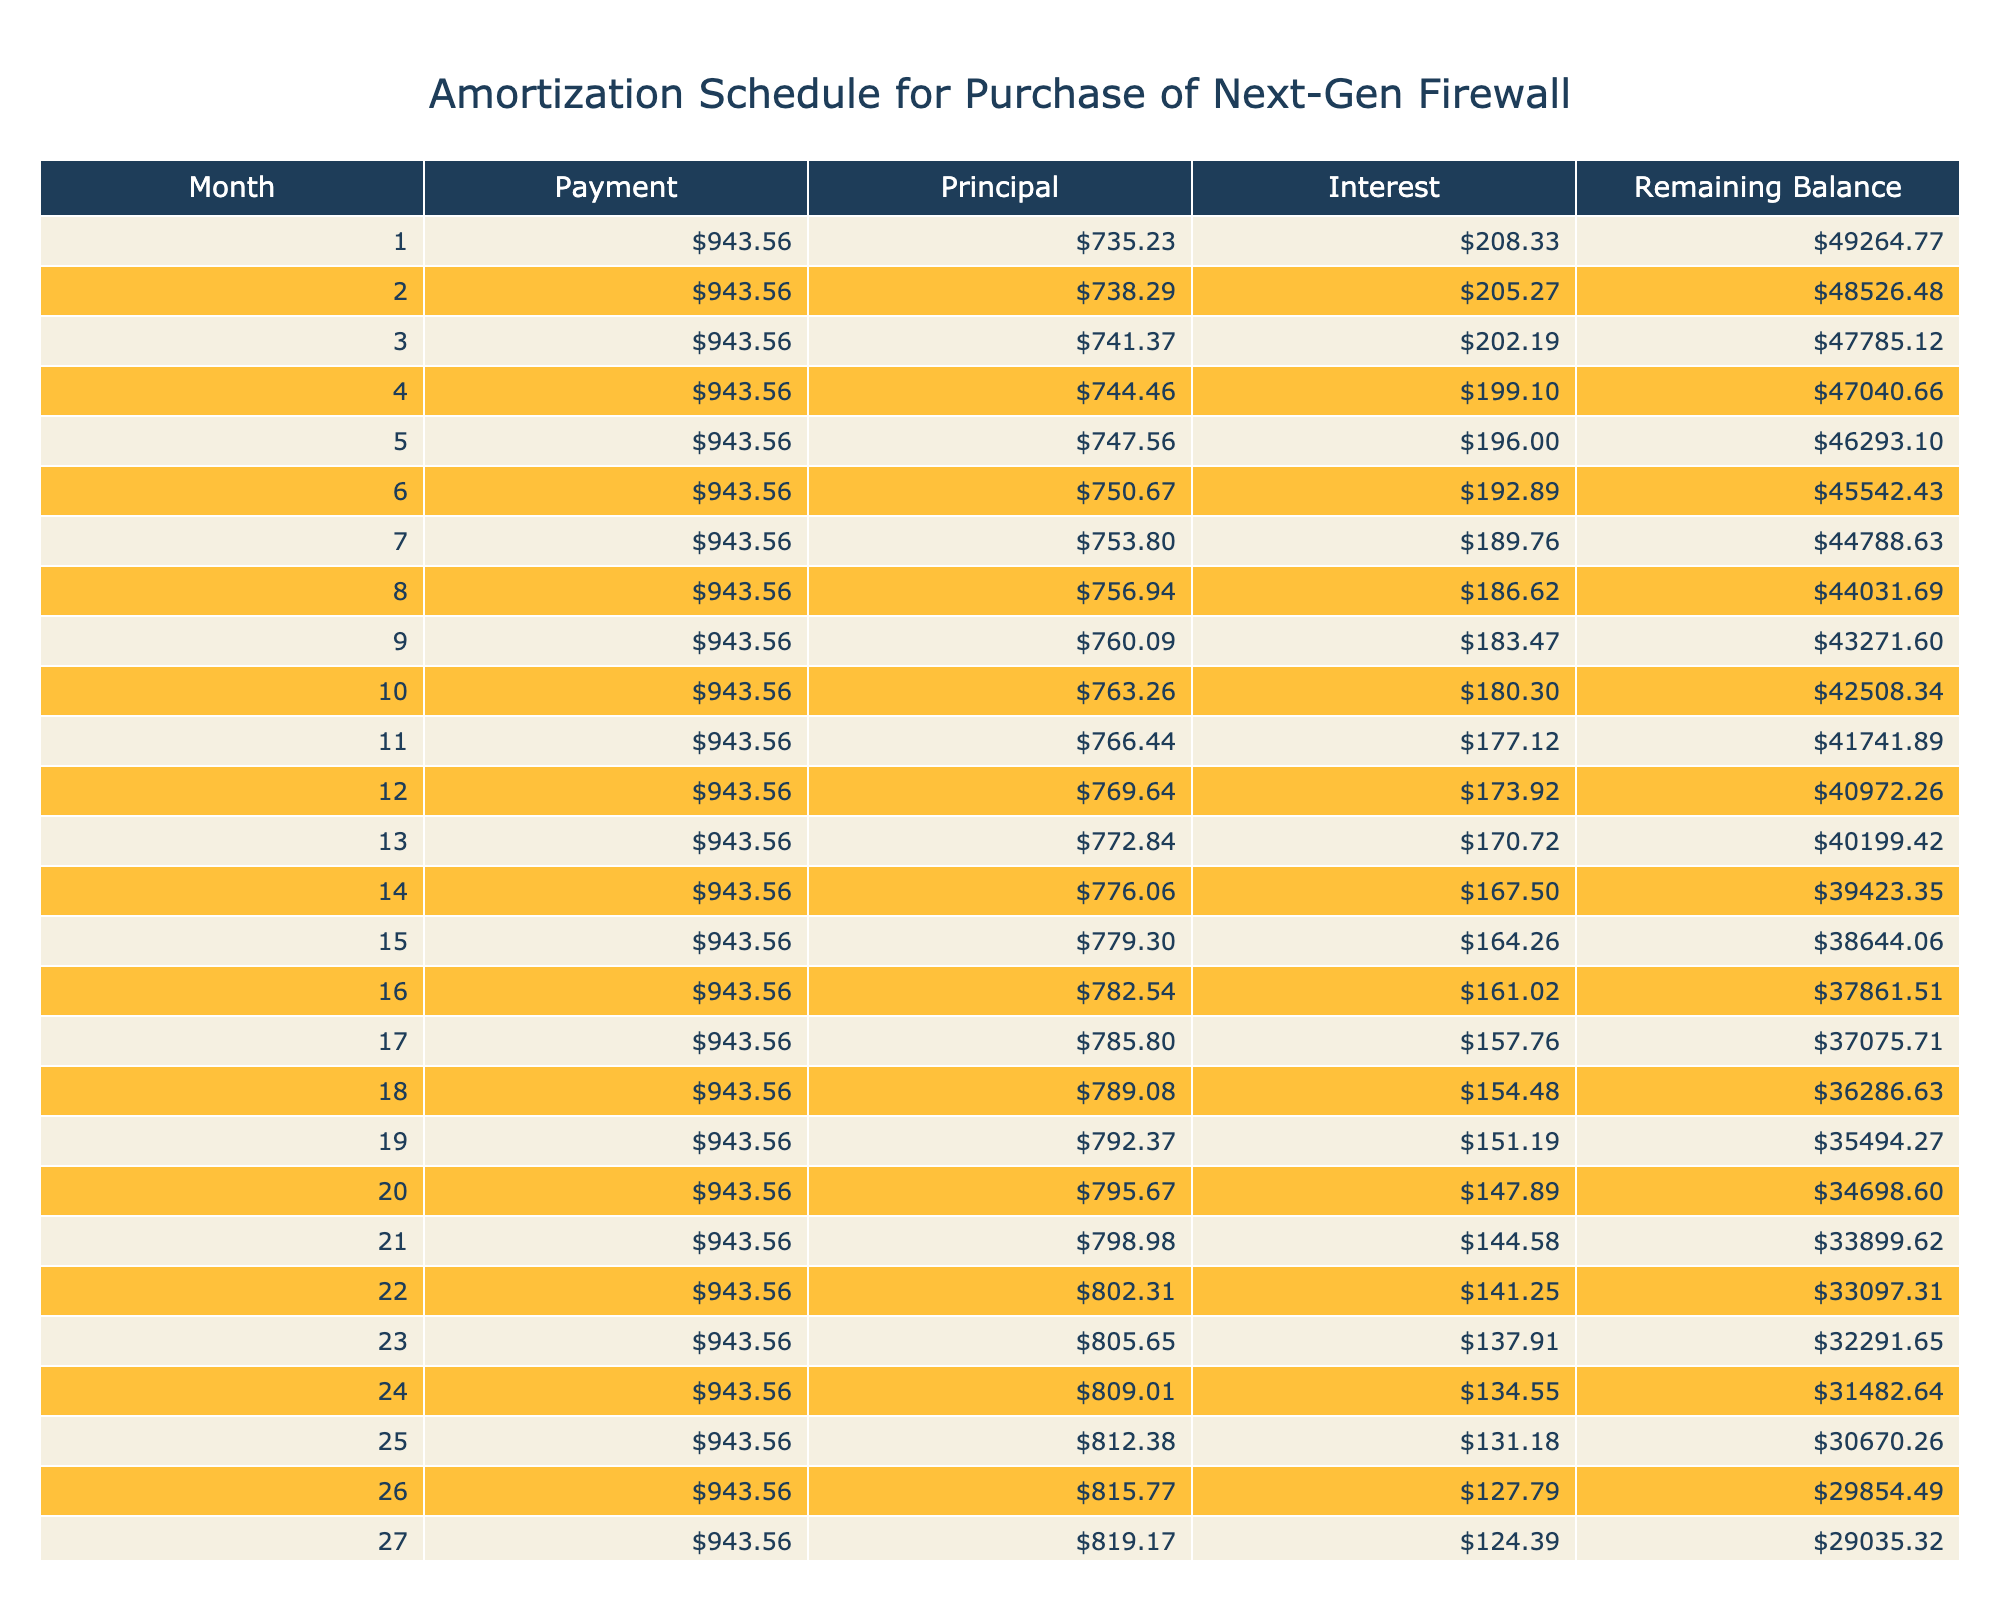What is the total payment made over the loan term? The total payment is listed directly in the table as $56,613.50, which is the sum of all monthly payments made over the 5-year term.
Answer: $56,613.50 What is the monthly payment amount for this loan? The monthly payment amount can be found in the table and is displayed as $943.56.
Answer: $943.56 Is the total interest paid over the course of the loan greater than $6,000? Yes, the total interest paid is $6,613.50, which is greater than $6,000.
Answer: Yes What was the purpose of the loan? The purpose of the loan can be found in the table, which specifies that it was used for the "Purchase of Next-Gen Firewall."
Answer: Purchase of Next-Gen Firewall What is the difference between the total payment and the loan amount? The total payment is $56,613.50, and the loan amount is $50,000. The difference is calculated as $56,613.50 - $50,000 = $6,613.50, which represents the total interest paid.
Answer: $6,613.50 How much was the principal payment in the first month? For the first month, the principal payment is calculated by taking the monthly payment ($943.56) and subtracting the interest payment (which is the loan amount multiplied by the monthly interest rate). Thus, the interest payment is $50,000 * (5.0 / 100 / 12) = $208.33, so the principal payment is $943.56 - $208.33 = $735.23.
Answer: $735.23 What happens to the remaining balance over the course of the term? The remaining balance starts at $50,000 and decreases every month as payments are made. The final remaining balance after the last payment should be $0, indicating the loan is fully paid off at the end of 5 years.
Answer: Decreases to $0 What is the average monthly interest payment over the loan term? To find the average monthly interest payment, we first note the monthly interest payment on the initial loan amount is $208.33, and this amount will vary each month as the balance decreases. However, for simplicity, the average can be estimated by taking the total interest paid ($6,613.50) and dividing it by the term in months (60), resulting in an average monthly interest payment of approximately $110.22.
Answer: Approximately $110.22 In what month does the interest payment become less than $200? To find which month the interest payment falls below $200, we track the interest payments month by month. Specifically, after calculating the interest payment for the first several months, we find that the interest payment becomes less than $200 around month 30.
Answer: Month 30 